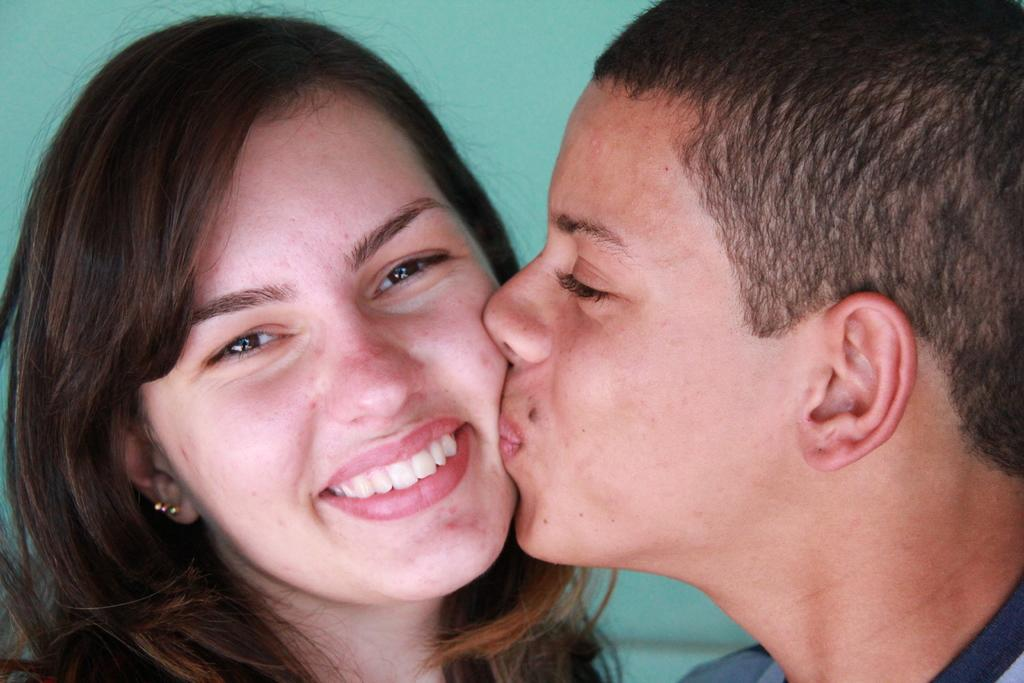How many people are present in the image? There are two persons in the image. What is the expression of the woman in the image? The woman is smiling. What action is the man performing in the image? The man is kissing the woman. What can be seen in the background of the image? There is a wall in the background of the image. How many boys are playing with the beetle in the image? There is no beetle or boys present in the image. What type of vessel is being used by the woman in the image? There is no vessel present in the image; it features two people interacting with each other. 